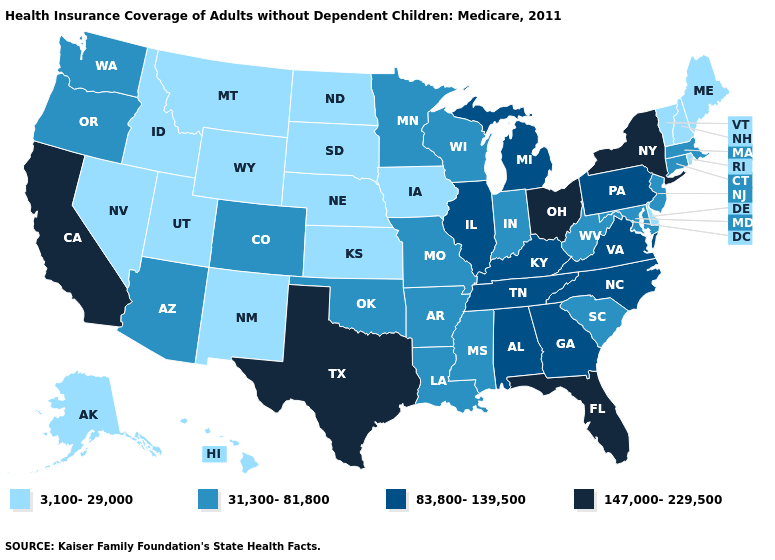Does North Dakota have the lowest value in the USA?
Concise answer only. Yes. What is the value of North Dakota?
Give a very brief answer. 3,100-29,000. Does the map have missing data?
Concise answer only. No. What is the value of Tennessee?
Give a very brief answer. 83,800-139,500. Does Georgia have a higher value than Texas?
Be succinct. No. Name the states that have a value in the range 83,800-139,500?
Give a very brief answer. Alabama, Georgia, Illinois, Kentucky, Michigan, North Carolina, Pennsylvania, Tennessee, Virginia. Does Iowa have the lowest value in the USA?
Concise answer only. Yes. Name the states that have a value in the range 31,300-81,800?
Keep it brief. Arizona, Arkansas, Colorado, Connecticut, Indiana, Louisiana, Maryland, Massachusetts, Minnesota, Mississippi, Missouri, New Jersey, Oklahoma, Oregon, South Carolina, Washington, West Virginia, Wisconsin. What is the lowest value in the USA?
Short answer required. 3,100-29,000. Does the first symbol in the legend represent the smallest category?
Concise answer only. Yes. What is the value of Iowa?
Quick response, please. 3,100-29,000. Name the states that have a value in the range 147,000-229,500?
Keep it brief. California, Florida, New York, Ohio, Texas. Name the states that have a value in the range 147,000-229,500?
Short answer required. California, Florida, New York, Ohio, Texas. Is the legend a continuous bar?
Keep it brief. No. Name the states that have a value in the range 83,800-139,500?
Give a very brief answer. Alabama, Georgia, Illinois, Kentucky, Michigan, North Carolina, Pennsylvania, Tennessee, Virginia. 